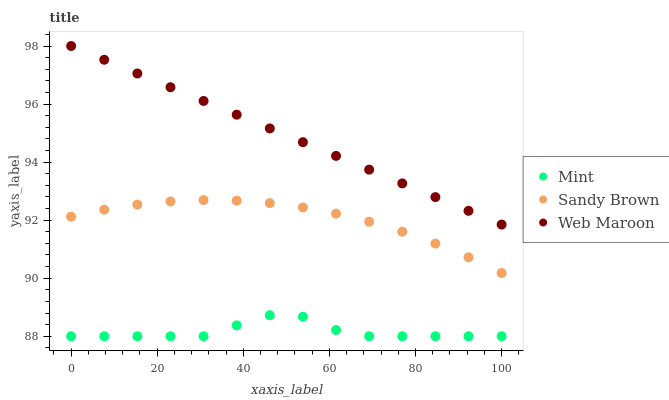Does Mint have the minimum area under the curve?
Answer yes or no. Yes. Does Web Maroon have the maximum area under the curve?
Answer yes or no. Yes. Does Web Maroon have the minimum area under the curve?
Answer yes or no. No. Does Mint have the maximum area under the curve?
Answer yes or no. No. Is Web Maroon the smoothest?
Answer yes or no. Yes. Is Mint the roughest?
Answer yes or no. Yes. Is Mint the smoothest?
Answer yes or no. No. Is Web Maroon the roughest?
Answer yes or no. No. Does Mint have the lowest value?
Answer yes or no. Yes. Does Web Maroon have the lowest value?
Answer yes or no. No. Does Web Maroon have the highest value?
Answer yes or no. Yes. Does Mint have the highest value?
Answer yes or no. No. Is Mint less than Sandy Brown?
Answer yes or no. Yes. Is Web Maroon greater than Sandy Brown?
Answer yes or no. Yes. Does Mint intersect Sandy Brown?
Answer yes or no. No. 